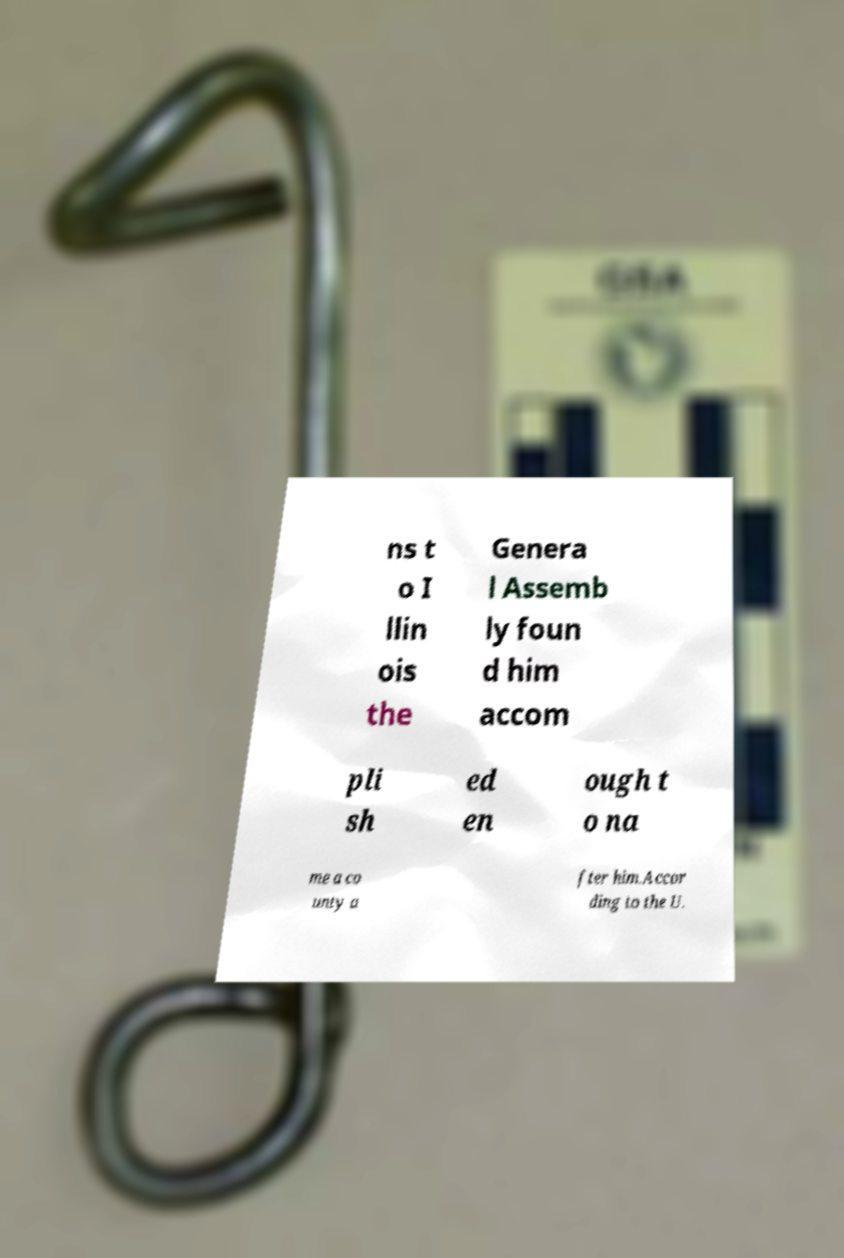I need the written content from this picture converted into text. Can you do that? ns t o I llin ois the Genera l Assemb ly foun d him accom pli sh ed en ough t o na me a co unty a fter him.Accor ding to the U. 